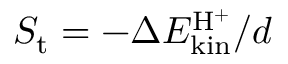Convert formula to latex. <formula><loc_0><loc_0><loc_500><loc_500>S _ { t } = - \Delta E _ { k i n } ^ { H ^ { + } } / d</formula> 